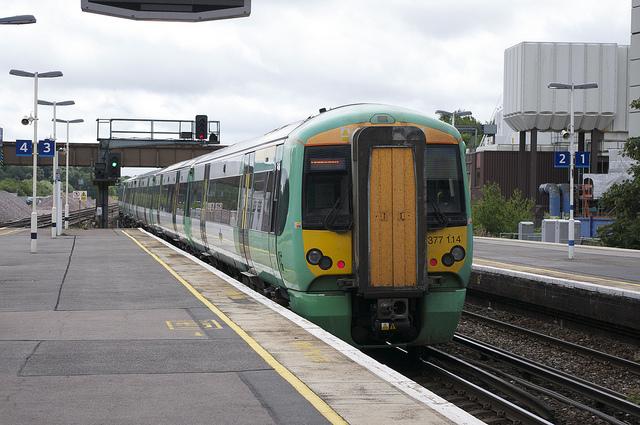How many trains are in the picture?
Answer briefly. 1. What kind of lines are on the walkway next to the train?
Quick response, please. Yellow. What color is the front of the train?
Concise answer only. Yellow. How is the weather?
Quick response, please. Cloudy. Is the train in the center yellow?
Answer briefly. Yes. What colors are the train?
Write a very short answer. Green and yellow. How many trains are in the photo?
Be succinct. 1. What color is the building in the background?
Answer briefly. White. Is this a big train station?
Write a very short answer. No. 